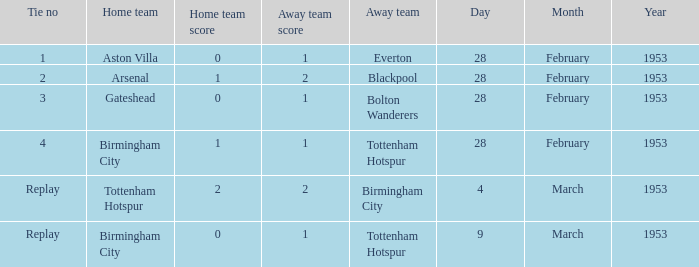Can you give me this table as a dict? {'header': ['Tie no', 'Home team', 'Home team score', 'Away team score', 'Away team', 'Day', 'Month', 'Year'], 'rows': [['1', 'Aston Villa', '0', '1', 'Everton', '28', 'February', '1953'], ['2', 'Arsenal', '1', '2', 'Blackpool', '28', 'February', '1953'], ['3', 'Gateshead', '0', '1', 'Bolton Wanderers', '28', 'February', '1953'], ['4', 'Birmingham City', '1', '1', 'Tottenham Hotspur', '28', 'February', '1953'], ['Replay', 'Tottenham Hotspur', '2', '2', 'Birmingham City', '4', 'March', '1953'], ['Replay', 'Birmingham City', '0', '1', 'Tottenham Hotspur', '9', 'March', '1953']]} Which home team has a score of 0-1 with tottenham hotspur as the away team? Birmingham City. 